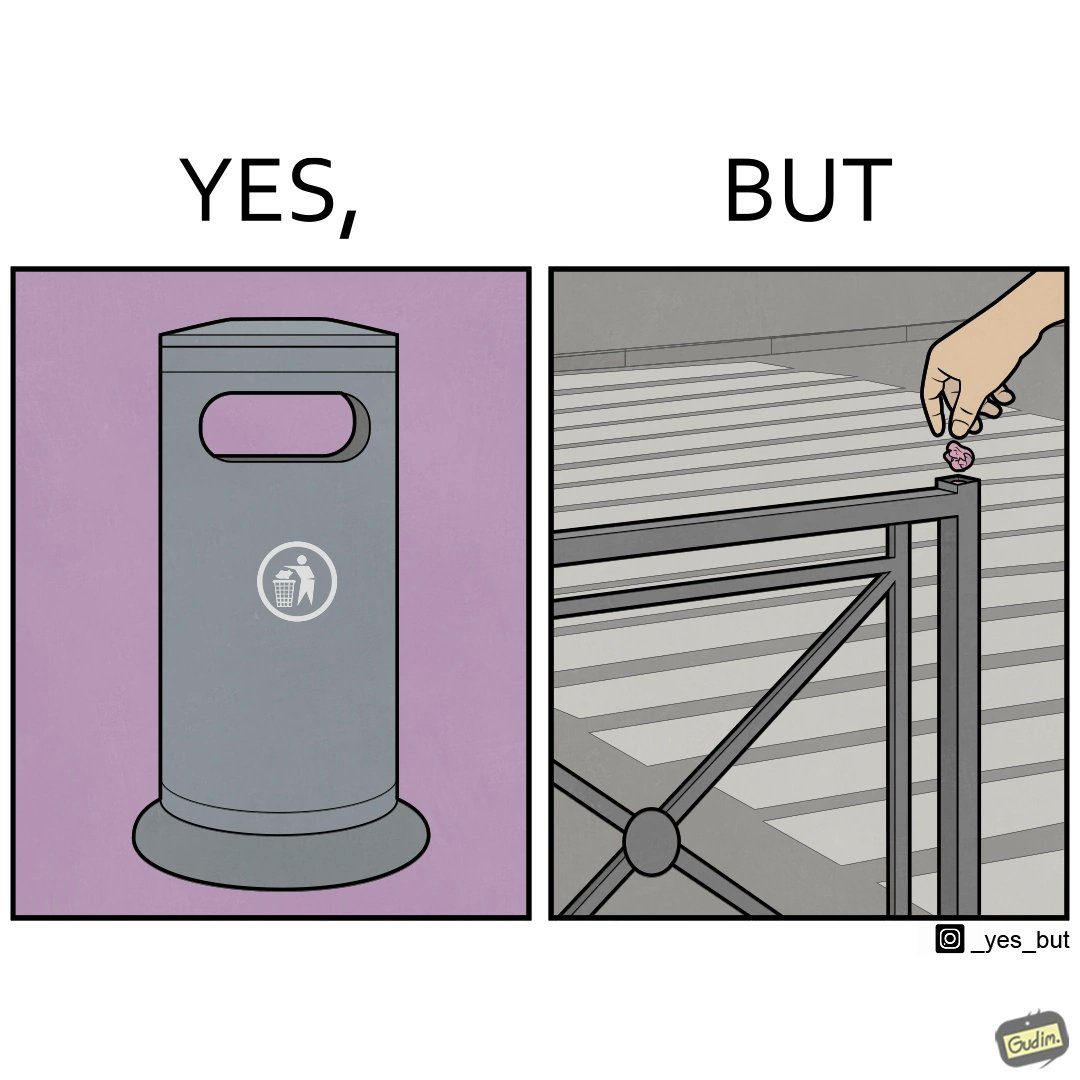What does this image depict? The images are ironic because even though garbage bins are provided for humans to dispose waste, by habit humans still choose to make surroundings dirty by disposing garbage improperly 